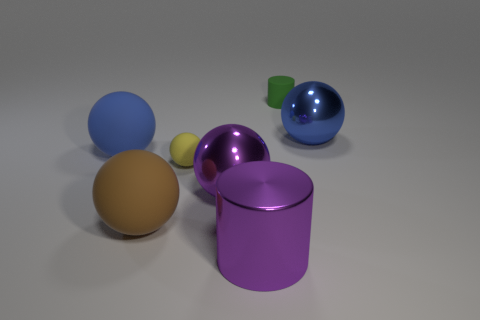What number of large objects are metallic balls or gray cylinders?
Provide a succinct answer. 2. What size is the metallic sphere that is the same color as the big cylinder?
Your answer should be very brief. Large. What is the color of the cylinder in front of the metallic sphere that is to the right of the green thing?
Keep it short and to the point. Purple. Is the material of the big cylinder the same as the blue ball that is on the right side of the purple ball?
Provide a short and direct response. Yes. What is the material of the large blue object to the left of the yellow sphere?
Keep it short and to the point. Rubber. Is the number of big brown things behind the large brown thing the same as the number of gray cubes?
Provide a short and direct response. Yes. There is a cylinder that is in front of the shiny thing that is behind the small matte ball; what is its material?
Ensure brevity in your answer.  Metal. The thing that is both on the left side of the tiny rubber sphere and behind the brown thing has what shape?
Your answer should be compact. Sphere. There is a yellow thing that is the same shape as the large brown rubber thing; what is its size?
Your response must be concise. Small. Is the number of small rubber balls behind the yellow matte thing less than the number of cylinders?
Keep it short and to the point. Yes. 